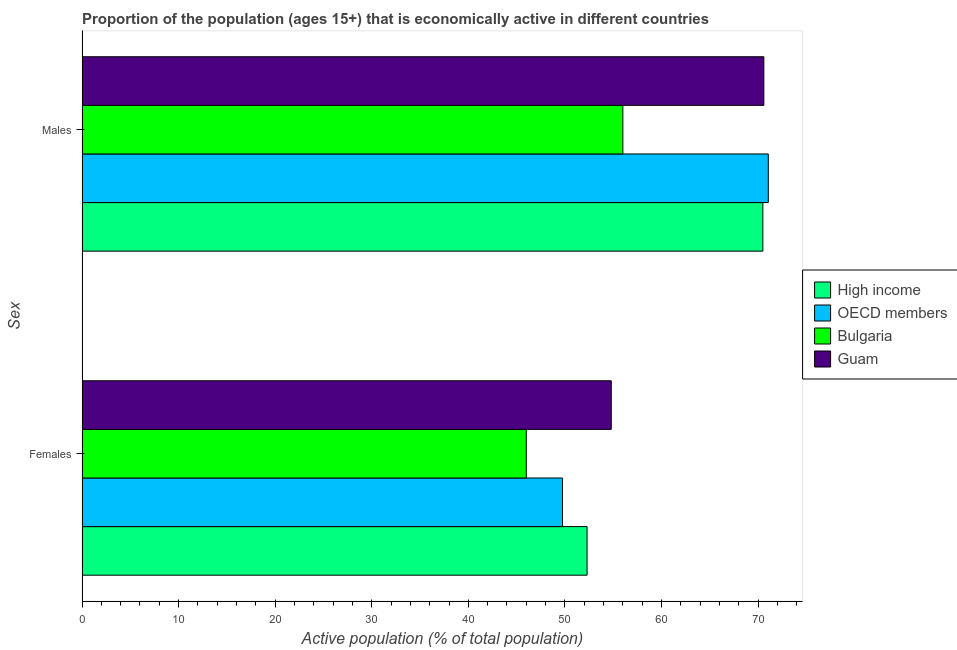How many different coloured bars are there?
Offer a terse response. 4. How many bars are there on the 1st tick from the top?
Your answer should be very brief. 4. How many bars are there on the 2nd tick from the bottom?
Ensure brevity in your answer.  4. What is the label of the 1st group of bars from the top?
Provide a succinct answer. Males. What is the percentage of economically active female population in High income?
Your answer should be compact. 52.29. Across all countries, what is the maximum percentage of economically active male population?
Offer a very short reply. 71.06. In which country was the percentage of economically active female population minimum?
Ensure brevity in your answer.  Bulgaria. What is the total percentage of economically active female population in the graph?
Your response must be concise. 202.84. What is the difference between the percentage of economically active female population in Bulgaria and that in OECD members?
Provide a short and direct response. -3.75. What is the difference between the percentage of economically active female population in Bulgaria and the percentage of economically active male population in OECD members?
Provide a short and direct response. -25.06. What is the average percentage of economically active female population per country?
Give a very brief answer. 50.71. What is the difference between the percentage of economically active male population and percentage of economically active female population in Bulgaria?
Give a very brief answer. 10. In how many countries, is the percentage of economically active male population greater than 2 %?
Make the answer very short. 4. What is the ratio of the percentage of economically active female population in Guam to that in Bulgaria?
Offer a very short reply. 1.19. Is the percentage of economically active male population in OECD members less than that in Bulgaria?
Provide a succinct answer. No. What does the 2nd bar from the bottom in Males represents?
Your answer should be compact. OECD members. How many bars are there?
Ensure brevity in your answer.  8. What is the difference between two consecutive major ticks on the X-axis?
Keep it short and to the point. 10. Does the graph contain grids?
Provide a short and direct response. No. What is the title of the graph?
Keep it short and to the point. Proportion of the population (ages 15+) that is economically active in different countries. Does "Russian Federation" appear as one of the legend labels in the graph?
Provide a short and direct response. No. What is the label or title of the X-axis?
Give a very brief answer. Active population (% of total population). What is the label or title of the Y-axis?
Your answer should be very brief. Sex. What is the Active population (% of total population) of High income in Females?
Your answer should be compact. 52.29. What is the Active population (% of total population) in OECD members in Females?
Your answer should be very brief. 49.75. What is the Active population (% of total population) of Guam in Females?
Your response must be concise. 54.8. What is the Active population (% of total population) of High income in Males?
Offer a terse response. 70.5. What is the Active population (% of total population) in OECD members in Males?
Offer a very short reply. 71.06. What is the Active population (% of total population) in Guam in Males?
Make the answer very short. 70.6. Across all Sex, what is the maximum Active population (% of total population) of High income?
Provide a succinct answer. 70.5. Across all Sex, what is the maximum Active population (% of total population) in OECD members?
Offer a very short reply. 71.06. Across all Sex, what is the maximum Active population (% of total population) in Guam?
Provide a succinct answer. 70.6. Across all Sex, what is the minimum Active population (% of total population) in High income?
Make the answer very short. 52.29. Across all Sex, what is the minimum Active population (% of total population) of OECD members?
Provide a succinct answer. 49.75. Across all Sex, what is the minimum Active population (% of total population) in Guam?
Provide a succinct answer. 54.8. What is the total Active population (% of total population) in High income in the graph?
Your answer should be compact. 122.79. What is the total Active population (% of total population) of OECD members in the graph?
Offer a terse response. 120.81. What is the total Active population (% of total population) in Bulgaria in the graph?
Your response must be concise. 102. What is the total Active population (% of total population) of Guam in the graph?
Make the answer very short. 125.4. What is the difference between the Active population (% of total population) of High income in Females and that in Males?
Your answer should be compact. -18.2. What is the difference between the Active population (% of total population) of OECD members in Females and that in Males?
Your answer should be compact. -21.31. What is the difference between the Active population (% of total population) of Bulgaria in Females and that in Males?
Your response must be concise. -10. What is the difference between the Active population (% of total population) in Guam in Females and that in Males?
Your response must be concise. -15.8. What is the difference between the Active population (% of total population) of High income in Females and the Active population (% of total population) of OECD members in Males?
Your answer should be very brief. -18.76. What is the difference between the Active population (% of total population) in High income in Females and the Active population (% of total population) in Bulgaria in Males?
Give a very brief answer. -3.71. What is the difference between the Active population (% of total population) in High income in Females and the Active population (% of total population) in Guam in Males?
Provide a succinct answer. -18.31. What is the difference between the Active population (% of total population) in OECD members in Females and the Active population (% of total population) in Bulgaria in Males?
Offer a terse response. -6.25. What is the difference between the Active population (% of total population) in OECD members in Females and the Active population (% of total population) in Guam in Males?
Keep it short and to the point. -20.85. What is the difference between the Active population (% of total population) in Bulgaria in Females and the Active population (% of total population) in Guam in Males?
Give a very brief answer. -24.6. What is the average Active population (% of total population) of High income per Sex?
Offer a terse response. 61.4. What is the average Active population (% of total population) of OECD members per Sex?
Offer a terse response. 60.4. What is the average Active population (% of total population) in Bulgaria per Sex?
Provide a short and direct response. 51. What is the average Active population (% of total population) in Guam per Sex?
Provide a short and direct response. 62.7. What is the difference between the Active population (% of total population) of High income and Active population (% of total population) of OECD members in Females?
Your answer should be compact. 2.55. What is the difference between the Active population (% of total population) in High income and Active population (% of total population) in Bulgaria in Females?
Your answer should be very brief. 6.29. What is the difference between the Active population (% of total population) in High income and Active population (% of total population) in Guam in Females?
Your answer should be very brief. -2.51. What is the difference between the Active population (% of total population) in OECD members and Active population (% of total population) in Bulgaria in Females?
Keep it short and to the point. 3.75. What is the difference between the Active population (% of total population) in OECD members and Active population (% of total population) in Guam in Females?
Keep it short and to the point. -5.05. What is the difference between the Active population (% of total population) of Bulgaria and Active population (% of total population) of Guam in Females?
Provide a succinct answer. -8.8. What is the difference between the Active population (% of total population) of High income and Active population (% of total population) of OECD members in Males?
Give a very brief answer. -0.56. What is the difference between the Active population (% of total population) in High income and Active population (% of total population) in Bulgaria in Males?
Ensure brevity in your answer.  14.5. What is the difference between the Active population (% of total population) in High income and Active population (% of total population) in Guam in Males?
Keep it short and to the point. -0.1. What is the difference between the Active population (% of total population) in OECD members and Active population (% of total population) in Bulgaria in Males?
Keep it short and to the point. 15.06. What is the difference between the Active population (% of total population) in OECD members and Active population (% of total population) in Guam in Males?
Give a very brief answer. 0.46. What is the difference between the Active population (% of total population) in Bulgaria and Active population (% of total population) in Guam in Males?
Offer a very short reply. -14.6. What is the ratio of the Active population (% of total population) of High income in Females to that in Males?
Your response must be concise. 0.74. What is the ratio of the Active population (% of total population) in OECD members in Females to that in Males?
Keep it short and to the point. 0.7. What is the ratio of the Active population (% of total population) in Bulgaria in Females to that in Males?
Offer a very short reply. 0.82. What is the ratio of the Active population (% of total population) in Guam in Females to that in Males?
Ensure brevity in your answer.  0.78. What is the difference between the highest and the second highest Active population (% of total population) of High income?
Offer a terse response. 18.2. What is the difference between the highest and the second highest Active population (% of total population) in OECD members?
Offer a very short reply. 21.31. What is the difference between the highest and the second highest Active population (% of total population) of Guam?
Ensure brevity in your answer.  15.8. What is the difference between the highest and the lowest Active population (% of total population) of High income?
Your answer should be very brief. 18.2. What is the difference between the highest and the lowest Active population (% of total population) in OECD members?
Give a very brief answer. 21.31. What is the difference between the highest and the lowest Active population (% of total population) in Bulgaria?
Your response must be concise. 10. What is the difference between the highest and the lowest Active population (% of total population) of Guam?
Offer a terse response. 15.8. 